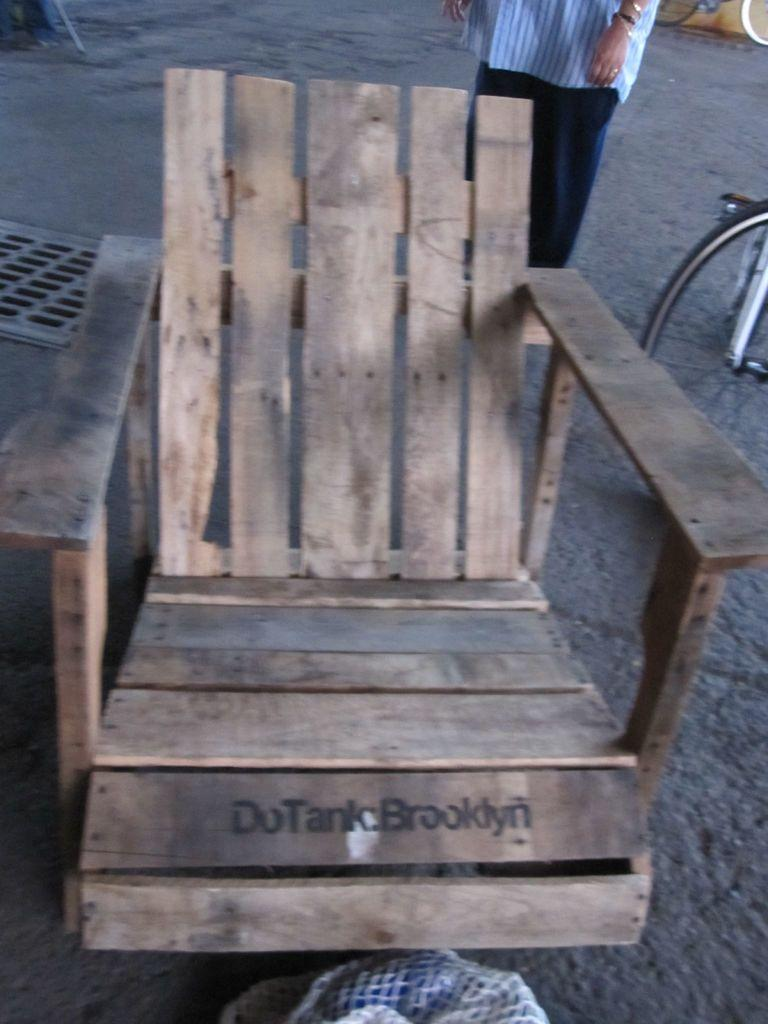What type of furniture is in the image? There is a wooden chair in the image. What other object can be seen in the image? There is a drainage cap in the image. Is there any transportation-related item in the image? Yes, a partial part of a bicycle is visible in the image. Can you describe the person in the image? There is a person in the image, but no specific details about the person are provided. What type of lunch is the person eating in the image? There is no lunch present in the image, as the facts provided do not mention any food items. Can you describe the doll that is sitting on the bicycle in the image? There is no doll present in the image; only a partial part of a bicycle is visible. 